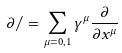<formula> <loc_0><loc_0><loc_500><loc_500>\partial / = \sum _ { \mu = 0 , 1 } \gamma ^ { \mu } \frac { \partial } { \partial x ^ { \mu } }</formula> 